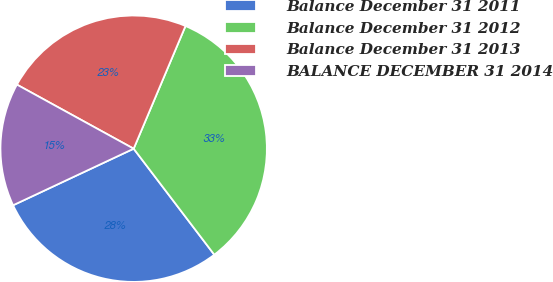<chart> <loc_0><loc_0><loc_500><loc_500><pie_chart><fcel>Balance December 31 2011<fcel>Balance December 31 2012<fcel>Balance December 31 2013<fcel>BALANCE DECEMBER 31 2014<nl><fcel>28.37%<fcel>33.29%<fcel>23.37%<fcel>14.97%<nl></chart> 